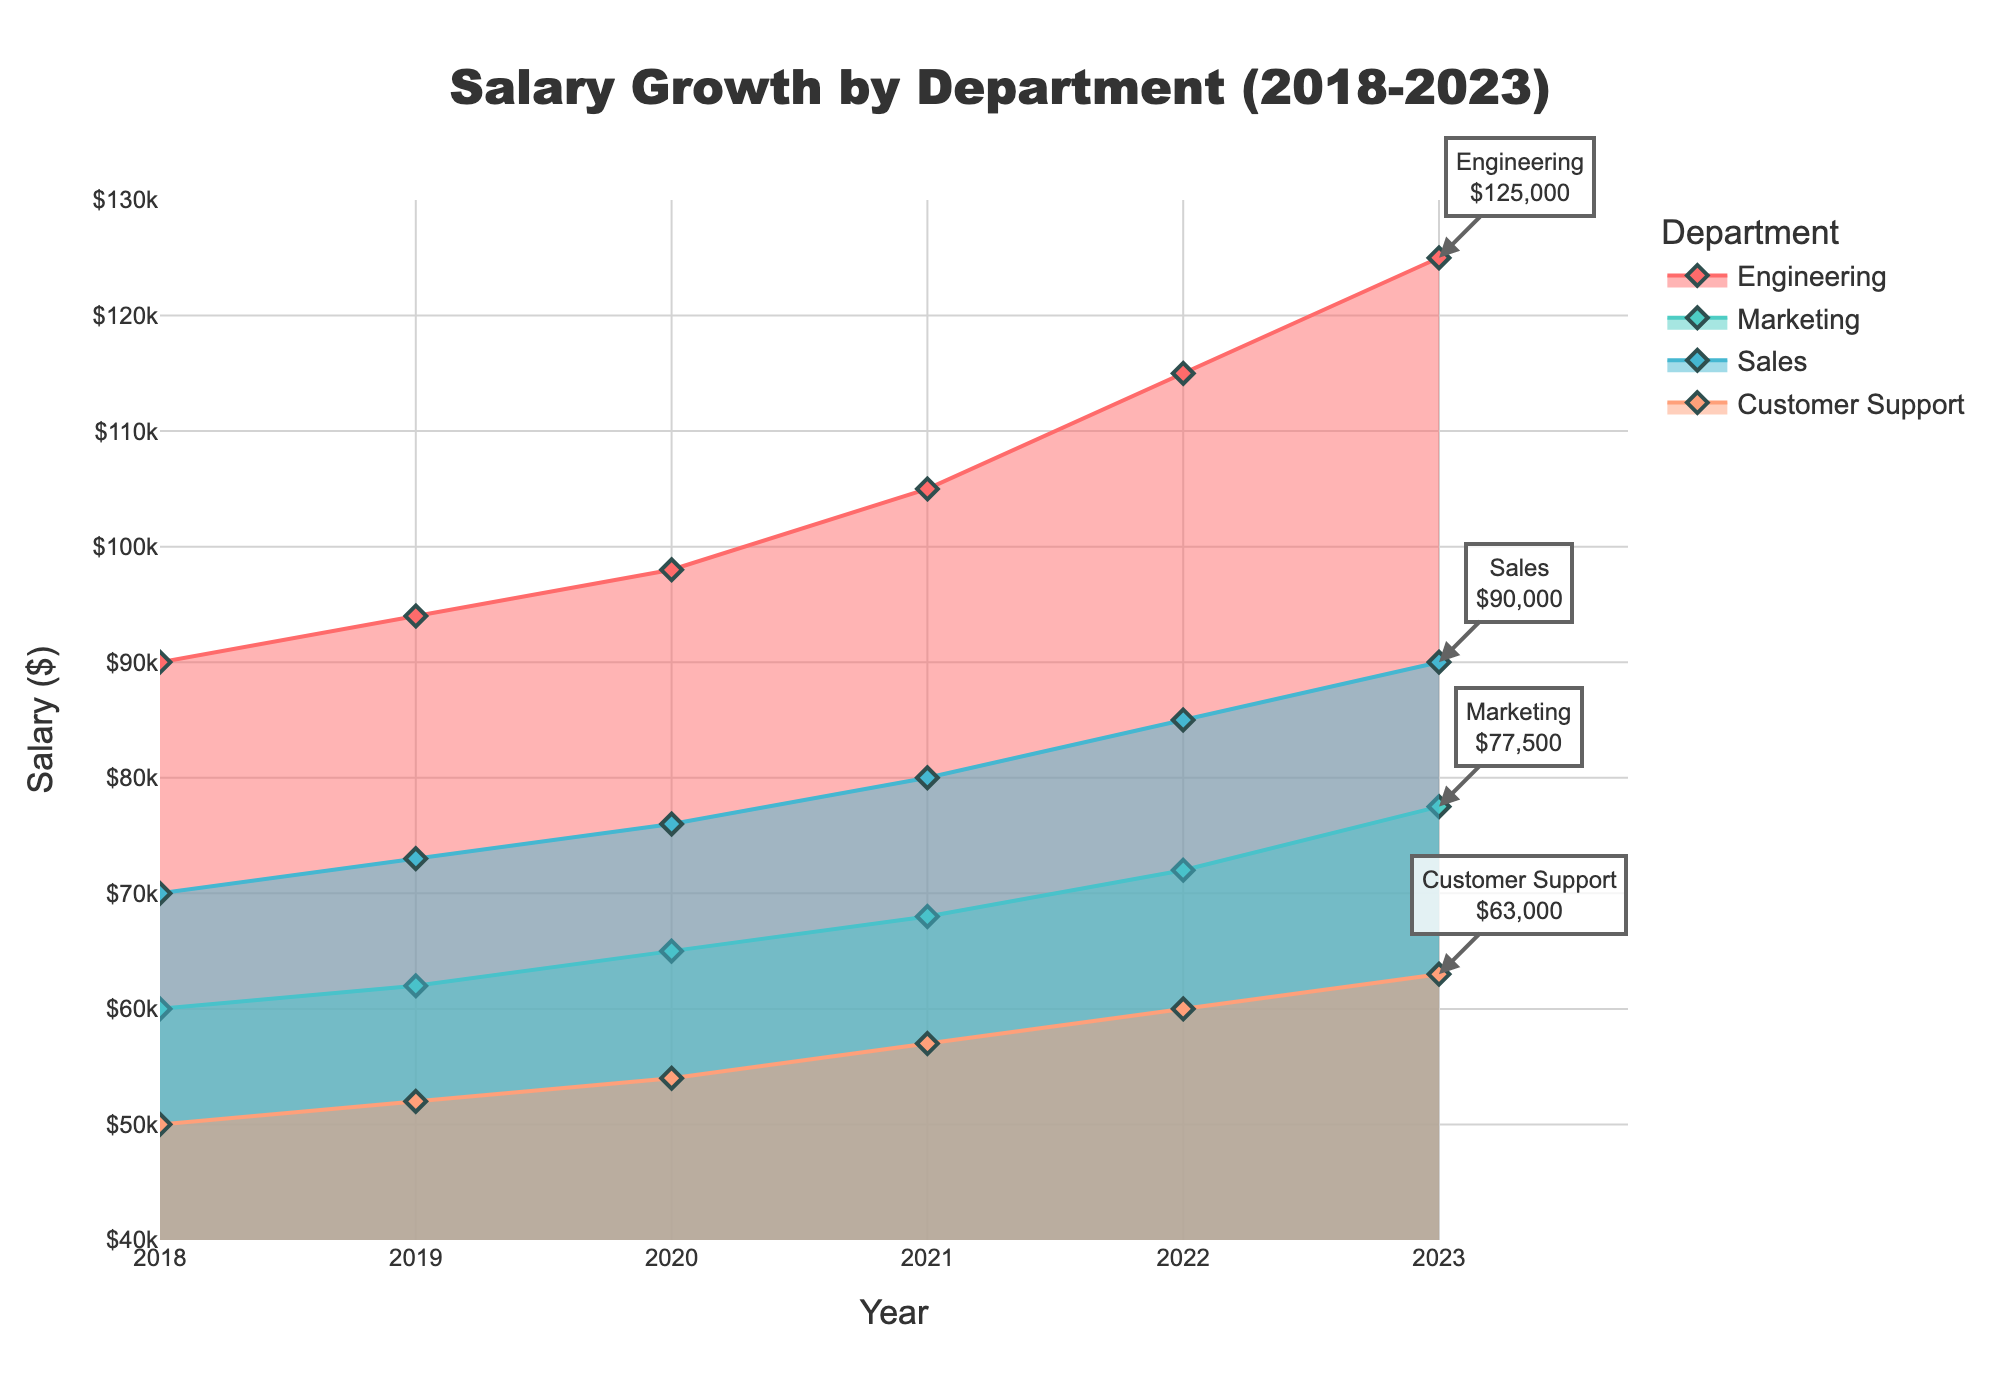What is the highest salary in 2023? The highest point in 2023 is for the Engineering department. The salary for Engineering in 2023 is at its highest value on the y-axis.
Answer: $125,000 Which department had the lowest salary in 2018? By looking at the leftmost points on the x-axis for 2018, we see that Customer Support has the lowest salary. It is lower compared to Engineering, Marketing, and Sales.
Answer: Customer Support How much did the salary for the Sales department increase from 2018 to 2023? From the 2018 point for Sales at $70,000 to the 2023 point at $90,000, the increase is $90,000 - $70,000.
Answer: $20,000 Which department showed the most significant growth in salary from 2018 to 2023? By comparing the starting and ending points of each department, Engineering has the most considerable growth from $90,000 in 2018 to $125,000 in 2023.
Answer: Engineering How does the salary change trend for Marketing compare to Customer Support over the years? By following the filled area lines for Marketing and Customer Support, Marketing starts at a higher value and consistently increases, showing a greater overall increase compared to Customer Support which starts lower and increases at a slower rate.
Answer: Marketing shows a greater increase What is the total salary increase for the Engineering department from 2018 to 2023? The total increase is calculated by the final value of 2023 minus the initial value of 2018 for Engineering: $125,000 - $90,000.
Answer: $35,000 In which year did Marketing and Sales touch the same salary mark? By examining the lines for Marketing and Sales, they both reach the same salary point at approximately $62,000 around the year 2019.
Answer: 2019 Which department has the smallest salary range over the six years? By observing the vertical spread of each department's range from 2018 to 2023, Customer Support has the smallest range (from $50,000 to $63,000, which is the narrowest).
Answer: Customer Support What is the average salary for the Engineering department over the six years? Add the salaries for Engineering from each year (90,000 + 94,000 + 98,000 + 105,000 + 115,000 + 125,000) and divide by 6. The sum is 627,000, and the average is 627,000 / 6.
Answer: $104,500 Which year shows the highest rate of salary increase for the Engineering department? By comparing the slopes of the Engineering line year-over-year, the jump from 2020 ($98,000) to 2021 ($105,000) seems the steepest. The increase is $7,000.
Answer: 2021 